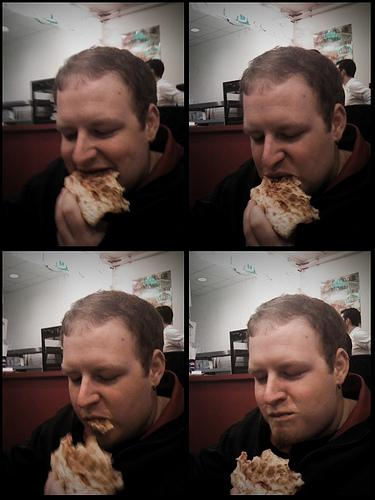Question: what is he eating?
Choices:
A. A burrito.
B. A piece of fried chicken.
C. A cheeseburger.
D. A serving of pork nachos.
Answer with the letter. Answer: A Question: why is the man eating?
Choices:
A. He is trying to add more calories to his diet today.
B. He is feeling weak so he felt he should eat.
C. He needs something to raise his sugar level.
D. He is hungry.
Answer with the letter. Answer: D Question: who is by the wall?
Choices:
A. A priest.
B. A man.
C. A nun.
D. A woman.
Answer with the letter. Answer: B Question: how many pictures are there?
Choices:
A. 1.
B. 2.
C. 3.
D. 4.
Answer with the letter. Answer: D Question: where is the man?
Choices:
A. A grocery store.
B. A building supply store.
C. A restaurant.
D. A discount store.
Answer with the letter. Answer: C 